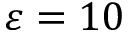<formula> <loc_0><loc_0><loc_500><loc_500>\varepsilon = 1 0</formula> 